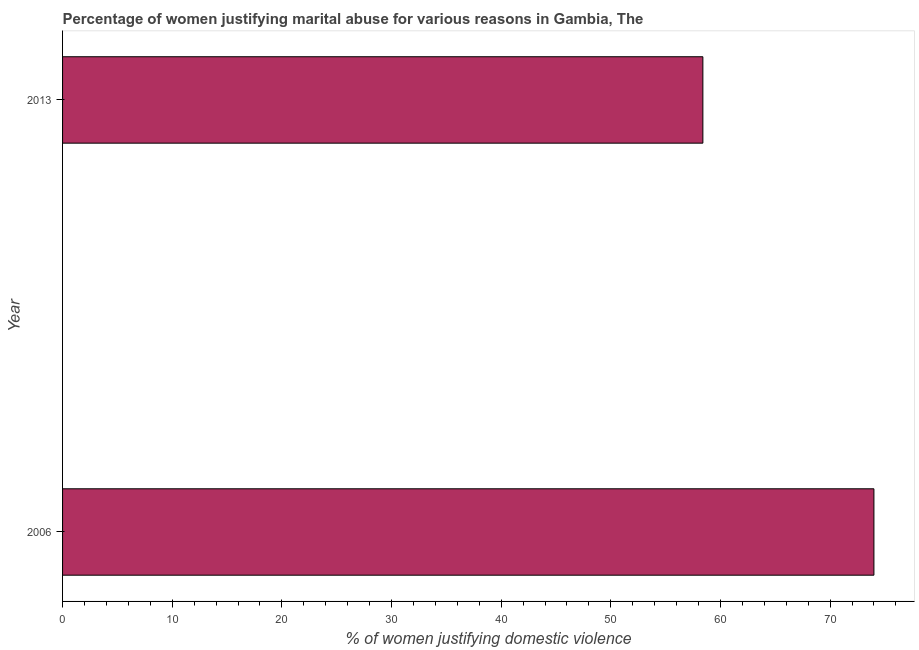Does the graph contain any zero values?
Provide a short and direct response. No. Does the graph contain grids?
Offer a very short reply. No. What is the title of the graph?
Your answer should be compact. Percentage of women justifying marital abuse for various reasons in Gambia, The. What is the label or title of the X-axis?
Keep it short and to the point. % of women justifying domestic violence. What is the label or title of the Y-axis?
Keep it short and to the point. Year. What is the percentage of women justifying marital abuse in 2013?
Ensure brevity in your answer.  58.4. Across all years, what is the maximum percentage of women justifying marital abuse?
Offer a very short reply. 74. Across all years, what is the minimum percentage of women justifying marital abuse?
Keep it short and to the point. 58.4. In which year was the percentage of women justifying marital abuse minimum?
Ensure brevity in your answer.  2013. What is the sum of the percentage of women justifying marital abuse?
Provide a short and direct response. 132.4. What is the difference between the percentage of women justifying marital abuse in 2006 and 2013?
Ensure brevity in your answer.  15.6. What is the average percentage of women justifying marital abuse per year?
Ensure brevity in your answer.  66.2. What is the median percentage of women justifying marital abuse?
Ensure brevity in your answer.  66.2. Do a majority of the years between 2006 and 2013 (inclusive) have percentage of women justifying marital abuse greater than 14 %?
Provide a short and direct response. Yes. What is the ratio of the percentage of women justifying marital abuse in 2006 to that in 2013?
Offer a terse response. 1.27. How many bars are there?
Provide a succinct answer. 2. What is the % of women justifying domestic violence in 2006?
Provide a short and direct response. 74. What is the % of women justifying domestic violence in 2013?
Your answer should be very brief. 58.4. What is the difference between the % of women justifying domestic violence in 2006 and 2013?
Your answer should be compact. 15.6. What is the ratio of the % of women justifying domestic violence in 2006 to that in 2013?
Offer a very short reply. 1.27. 